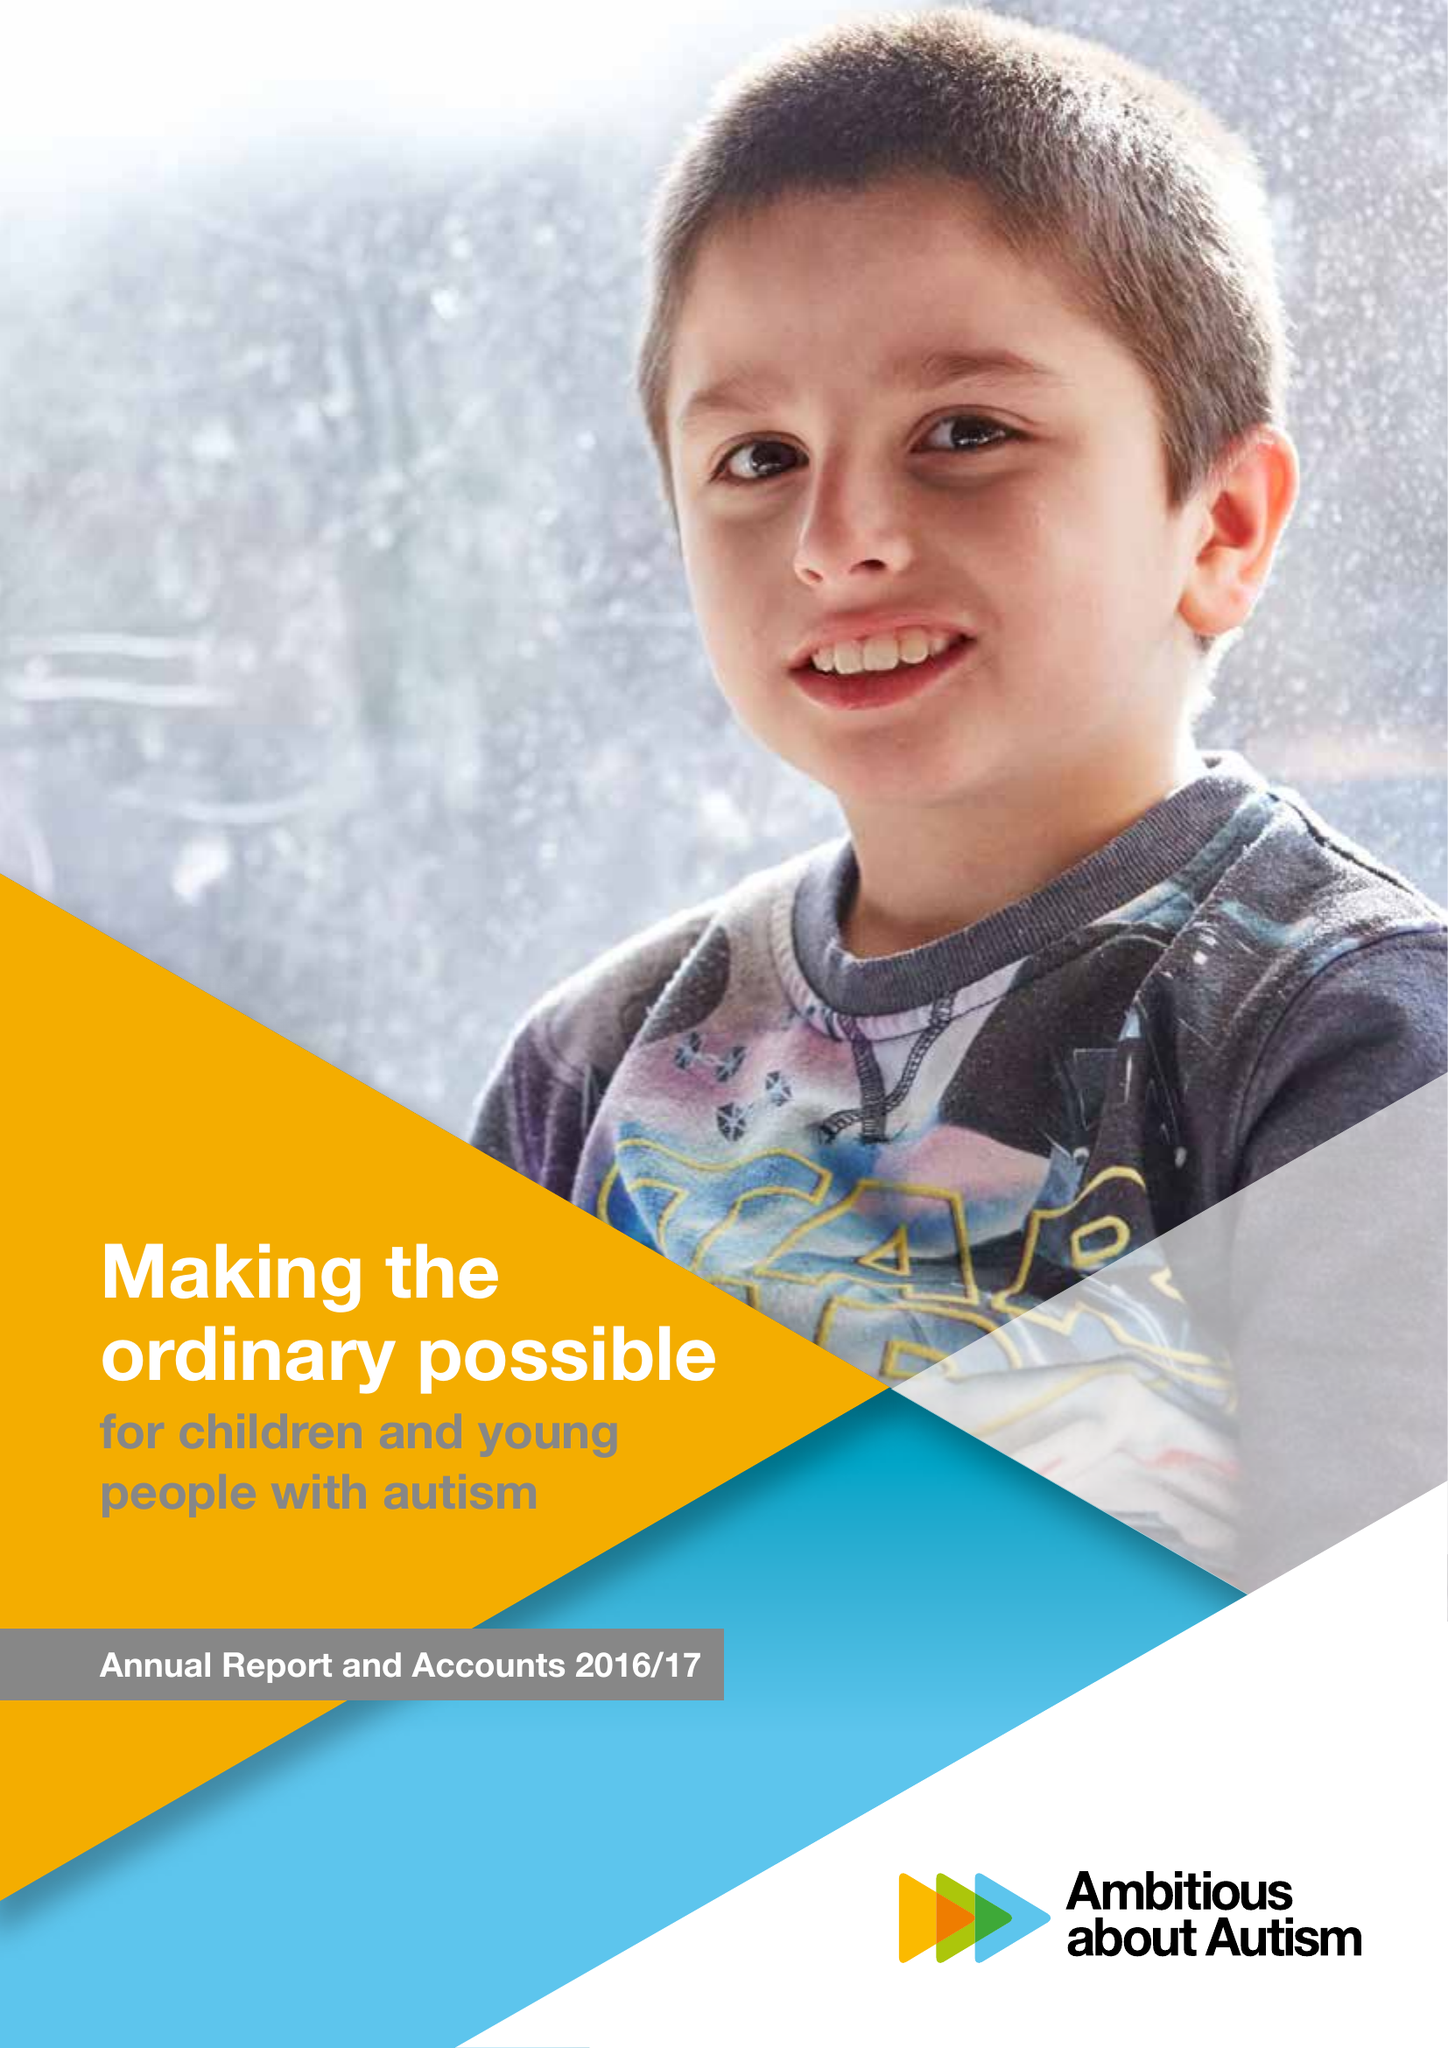What is the value for the charity_number?
Answer the question using a single word or phrase. 1063184 